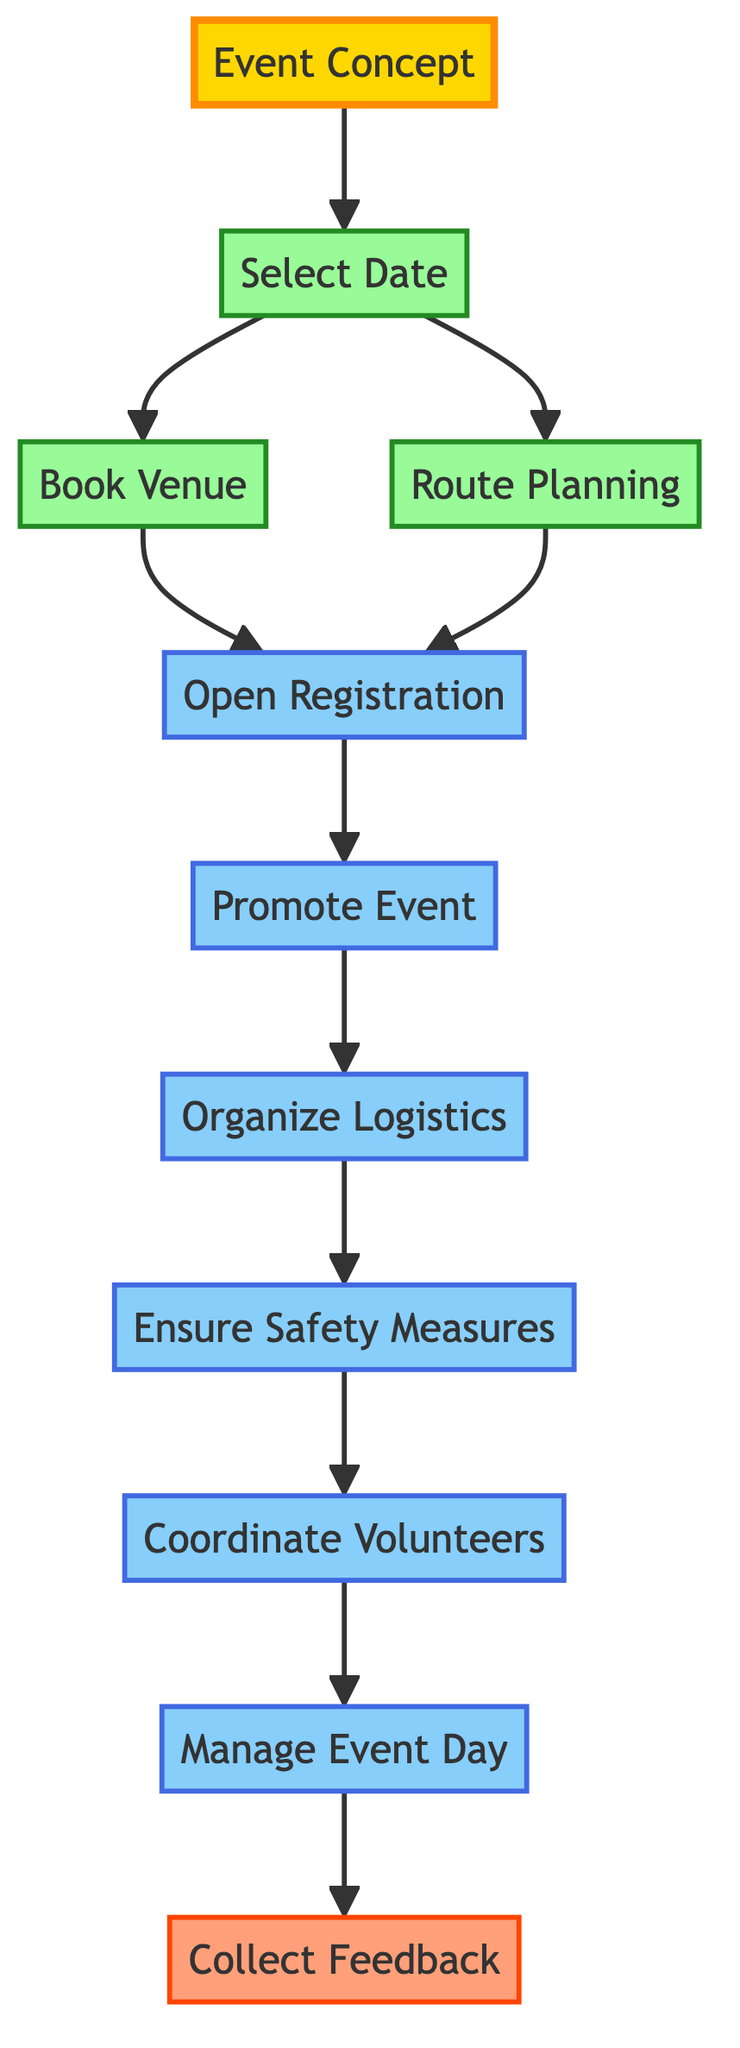What is the first step in the event planning process? The first step is represented by the node "Event Concept", which initiates the entire planning process for the cycling event.
Answer: Event Concept How many nodes are there in the diagram? By counting all unique nodes listed in the data section, there are 11 nodes total, showing different steps in the planning process.
Answer: 11 What is the node that follows "Open Registration"? The node that follows "Open Registration" is "Promote Event", showing that marketing activities should commence after registration is opened.
Answer: Promote Event Which nodes are dependent on "Select Date"? The nodes that depend on "Select Date" include "Book Venue" and "Route Planning", as they both need a confirmed date to proceed.
Answer: Book Venue, Route Planning What comes after "Manage Event Day"? After "Manage Event Day", the next step is "Collect Feedback", indicating that gathering participant impressions occurs after the event is managed.
Answer: Collect Feedback Which node has the most dependencies? The node "Participant Registration" has the most dependencies, as it is connected to "Book Venue" and "Route Planning" leading to it, and it also connects to "Promote Event" after registration.
Answer: Participant Registration What is the last node in the event planning process? The last node is "Collect Feedback", which summarizes the process by gathering impressions after the event is completed.
Answer: Collect Feedback Which node represents making arrangements for volunteers? The node that represents making arrangements for volunteers is "Coordinate Volunteers", which comes after ensuring safety measures are in place.
Answer: Coordinate Volunteers What is the direct connection between "Promote Event" and "Organize Logistics"? The direct connection indicates that promoting the event must occur before organizing logistics; thus, marketing directly influences logistical planning for the event.
Answer: Organize Logistics 